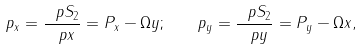Convert formula to latex. <formula><loc_0><loc_0><loc_500><loc_500>p _ { x } = \frac { \ p S _ { 2 } } { \ p x } = P _ { x } - \Omega y ; \quad p _ { y } = \frac { \ p S _ { 2 } } { \ p y } = P _ { y } - \Omega x ,</formula> 